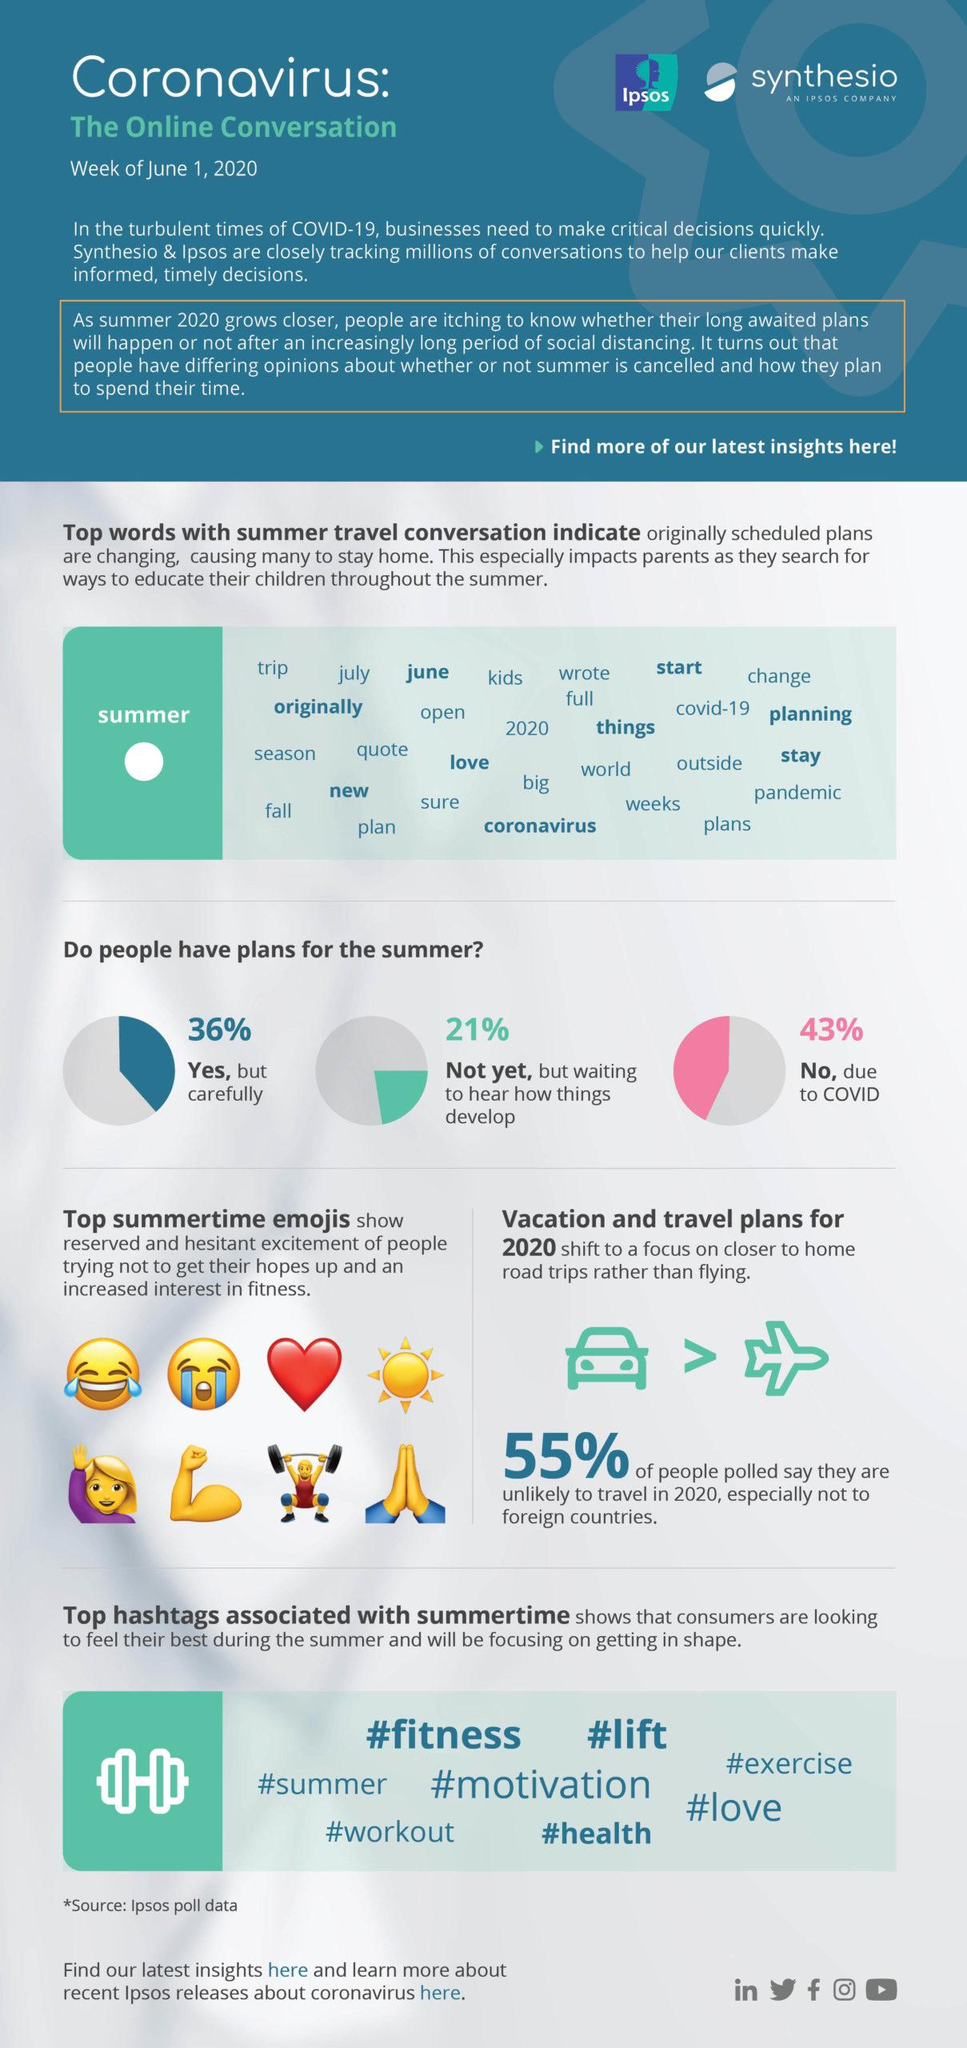List a handful of essential elements in this visual. Of the top summer emojis, 8 are shown. A recent survey found that 43% of people have not made any plans for the summer. According to the survey, 36% of people have made plans for the summer. According to the survey, 55% of the respondents stated that they will avoid traveling abroad in 2020. A recent survey has revealed that 21% of people have not yet made any plans for the summer. 